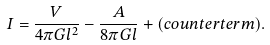<formula> <loc_0><loc_0><loc_500><loc_500>I = \frac { V } { 4 \pi G l ^ { 2 } } - \frac { A } { 8 \pi G l } + ( c o u n t e r t e r m ) .</formula> 